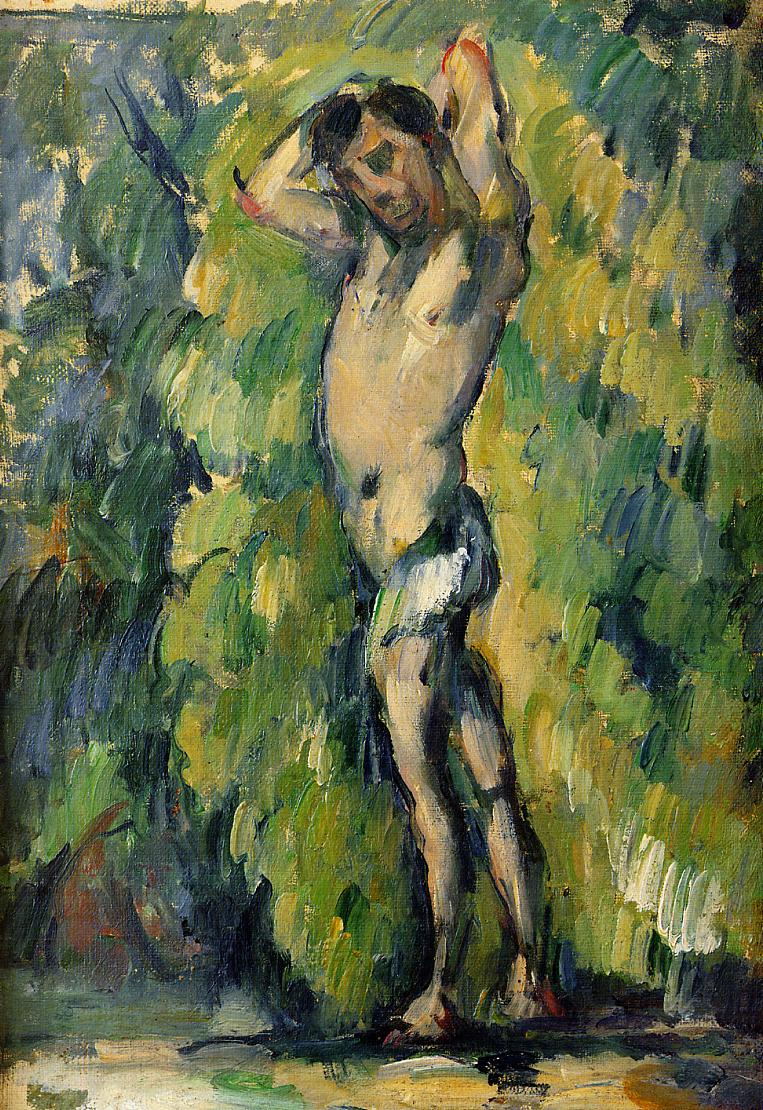Can you describe the emotion you perceive from the figure in this painting? The figure in the painting, with his arms raised and head slightly tilted back, exudes a sense of release or liberation. There's a certain tranquility in his posture, combined with a raw exposure to the elements around him. This might suggest a theme of harmony with nature or personal freedom. 